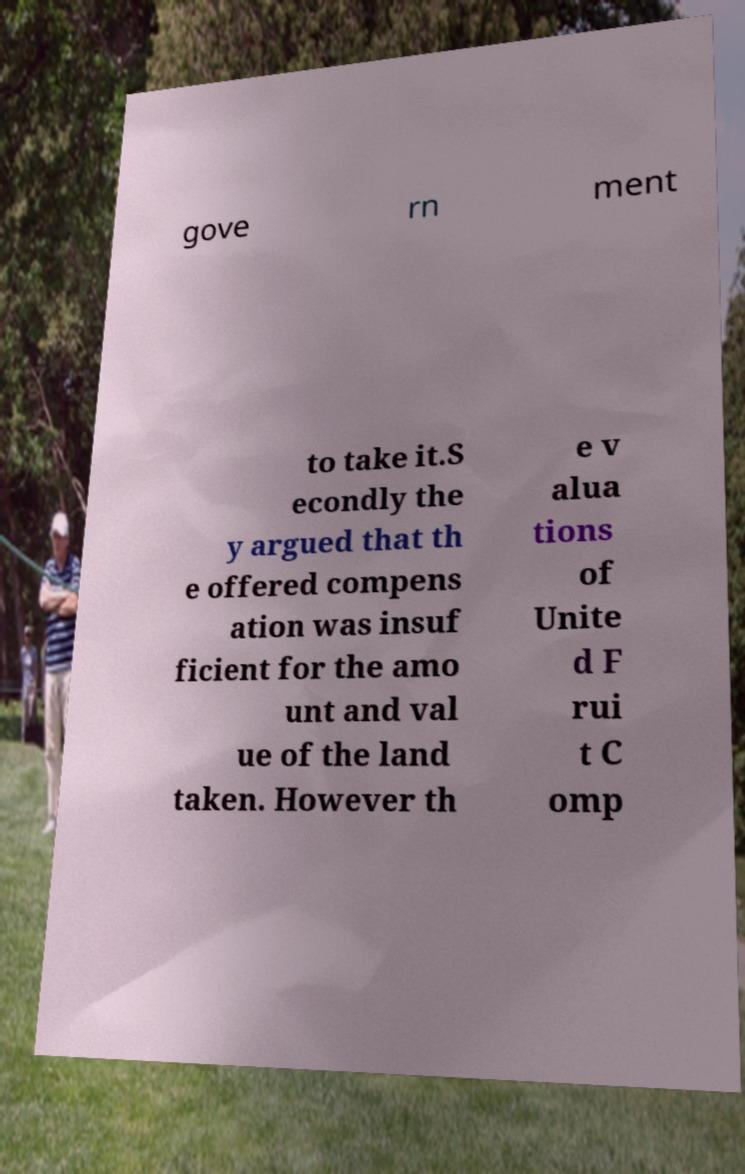Can you read and provide the text displayed in the image?This photo seems to have some interesting text. Can you extract and type it out for me? gove rn ment to take it.S econdly the y argued that th e offered compens ation was insuf ficient for the amo unt and val ue of the land taken. However th e v alua tions of Unite d F rui t C omp 